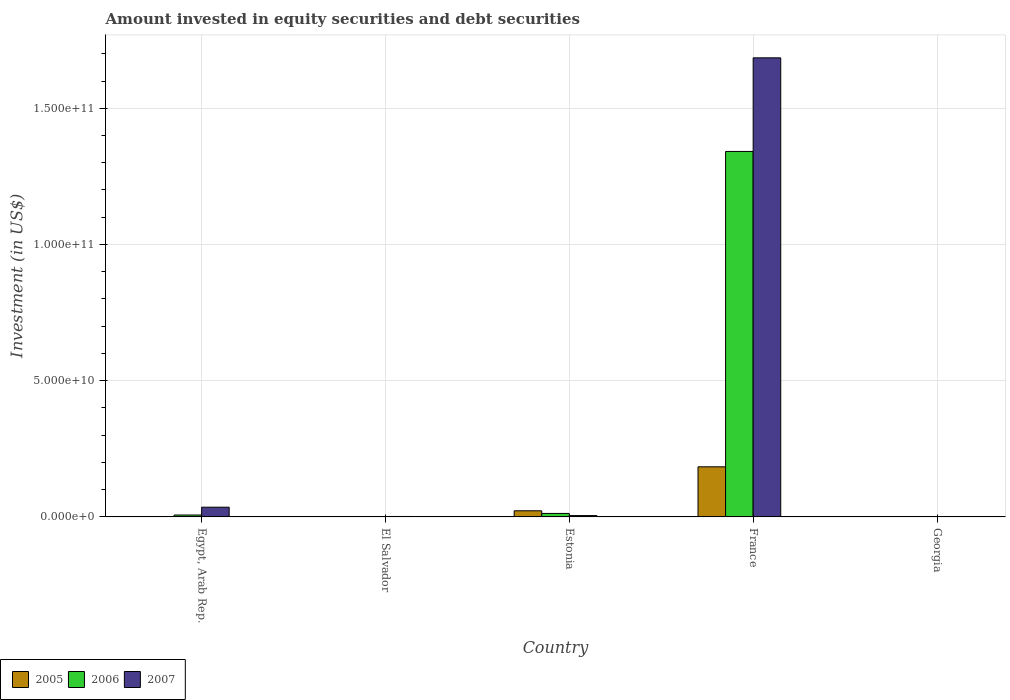Are the number of bars per tick equal to the number of legend labels?
Your answer should be very brief. No. What is the label of the 3rd group of bars from the left?
Your response must be concise. Estonia. What is the amount invested in equity securities and debt securities in 2007 in El Salvador?
Make the answer very short. 1.67e+08. Across all countries, what is the maximum amount invested in equity securities and debt securities in 2005?
Give a very brief answer. 1.84e+1. Across all countries, what is the minimum amount invested in equity securities and debt securities in 2005?
Offer a terse response. 0. What is the total amount invested in equity securities and debt securities in 2007 in the graph?
Offer a very short reply. 1.73e+11. What is the difference between the amount invested in equity securities and debt securities in 2007 in Egypt, Arab Rep. and that in France?
Make the answer very short. -1.65e+11. What is the difference between the amount invested in equity securities and debt securities in 2007 in Egypt, Arab Rep. and the amount invested in equity securities and debt securities in 2006 in Georgia?
Your response must be concise. 3.57e+09. What is the average amount invested in equity securities and debt securities in 2005 per country?
Your response must be concise. 4.13e+09. What is the difference between the amount invested in equity securities and debt securities of/in 2006 and amount invested in equity securities and debt securities of/in 2007 in Estonia?
Keep it short and to the point. 7.89e+08. In how many countries, is the amount invested in equity securities and debt securities in 2006 greater than 110000000000 US$?
Give a very brief answer. 1. What is the ratio of the amount invested in equity securities and debt securities in 2007 in Egypt, Arab Rep. to that in El Salvador?
Your response must be concise. 21.43. Is the difference between the amount invested in equity securities and debt securities in 2006 in Egypt, Arab Rep. and Estonia greater than the difference between the amount invested in equity securities and debt securities in 2007 in Egypt, Arab Rep. and Estonia?
Keep it short and to the point. No. What is the difference between the highest and the second highest amount invested in equity securities and debt securities in 2006?
Keep it short and to the point. 1.33e+11. What is the difference between the highest and the lowest amount invested in equity securities and debt securities in 2005?
Your response must be concise. 1.84e+1. How many countries are there in the graph?
Your answer should be compact. 5. Does the graph contain grids?
Keep it short and to the point. Yes. What is the title of the graph?
Give a very brief answer. Amount invested in equity securities and debt securities. Does "1980" appear as one of the legend labels in the graph?
Keep it short and to the point. No. What is the label or title of the X-axis?
Provide a short and direct response. Country. What is the label or title of the Y-axis?
Keep it short and to the point. Investment (in US$). What is the Investment (in US$) of 2005 in Egypt, Arab Rep.?
Your answer should be very brief. 0. What is the Investment (in US$) of 2006 in Egypt, Arab Rep.?
Your answer should be compact. 7.00e+08. What is the Investment (in US$) in 2007 in Egypt, Arab Rep.?
Make the answer very short. 3.57e+09. What is the Investment (in US$) of 2005 in El Salvador?
Your answer should be compact. 0. What is the Investment (in US$) of 2006 in El Salvador?
Your answer should be very brief. 0. What is the Investment (in US$) in 2007 in El Salvador?
Give a very brief answer. 1.67e+08. What is the Investment (in US$) of 2005 in Estonia?
Your response must be concise. 2.25e+09. What is the Investment (in US$) in 2006 in Estonia?
Ensure brevity in your answer.  1.28e+09. What is the Investment (in US$) in 2007 in Estonia?
Provide a succinct answer. 4.95e+08. What is the Investment (in US$) in 2005 in France?
Your response must be concise. 1.84e+1. What is the Investment (in US$) of 2006 in France?
Your answer should be compact. 1.34e+11. What is the Investment (in US$) of 2007 in France?
Offer a terse response. 1.69e+11. What is the Investment (in US$) in 2007 in Georgia?
Provide a succinct answer. 0. Across all countries, what is the maximum Investment (in US$) in 2005?
Your answer should be very brief. 1.84e+1. Across all countries, what is the maximum Investment (in US$) in 2006?
Your answer should be very brief. 1.34e+11. Across all countries, what is the maximum Investment (in US$) of 2007?
Your answer should be very brief. 1.69e+11. Across all countries, what is the minimum Investment (in US$) of 2005?
Offer a terse response. 0. Across all countries, what is the minimum Investment (in US$) of 2007?
Make the answer very short. 0. What is the total Investment (in US$) in 2005 in the graph?
Your answer should be very brief. 2.06e+1. What is the total Investment (in US$) of 2006 in the graph?
Offer a very short reply. 1.36e+11. What is the total Investment (in US$) of 2007 in the graph?
Your answer should be compact. 1.73e+11. What is the difference between the Investment (in US$) of 2007 in Egypt, Arab Rep. and that in El Salvador?
Offer a very short reply. 3.41e+09. What is the difference between the Investment (in US$) in 2006 in Egypt, Arab Rep. and that in Estonia?
Offer a very short reply. -5.83e+08. What is the difference between the Investment (in US$) in 2007 in Egypt, Arab Rep. and that in Estonia?
Keep it short and to the point. 3.08e+09. What is the difference between the Investment (in US$) of 2006 in Egypt, Arab Rep. and that in France?
Your answer should be compact. -1.33e+11. What is the difference between the Investment (in US$) in 2007 in Egypt, Arab Rep. and that in France?
Provide a succinct answer. -1.65e+11. What is the difference between the Investment (in US$) of 2007 in El Salvador and that in Estonia?
Make the answer very short. -3.28e+08. What is the difference between the Investment (in US$) in 2007 in El Salvador and that in France?
Keep it short and to the point. -1.68e+11. What is the difference between the Investment (in US$) in 2005 in Estonia and that in France?
Ensure brevity in your answer.  -1.61e+1. What is the difference between the Investment (in US$) in 2006 in Estonia and that in France?
Provide a succinct answer. -1.33e+11. What is the difference between the Investment (in US$) of 2007 in Estonia and that in France?
Give a very brief answer. -1.68e+11. What is the difference between the Investment (in US$) in 2006 in Egypt, Arab Rep. and the Investment (in US$) in 2007 in El Salvador?
Offer a terse response. 5.34e+08. What is the difference between the Investment (in US$) in 2006 in Egypt, Arab Rep. and the Investment (in US$) in 2007 in Estonia?
Your answer should be compact. 2.06e+08. What is the difference between the Investment (in US$) in 2006 in Egypt, Arab Rep. and the Investment (in US$) in 2007 in France?
Your answer should be compact. -1.68e+11. What is the difference between the Investment (in US$) of 2005 in Estonia and the Investment (in US$) of 2006 in France?
Keep it short and to the point. -1.32e+11. What is the difference between the Investment (in US$) in 2005 in Estonia and the Investment (in US$) in 2007 in France?
Your answer should be very brief. -1.66e+11. What is the difference between the Investment (in US$) in 2006 in Estonia and the Investment (in US$) in 2007 in France?
Give a very brief answer. -1.67e+11. What is the average Investment (in US$) of 2005 per country?
Your answer should be very brief. 4.13e+09. What is the average Investment (in US$) of 2006 per country?
Offer a very short reply. 2.72e+1. What is the average Investment (in US$) in 2007 per country?
Your answer should be compact. 3.45e+1. What is the difference between the Investment (in US$) in 2006 and Investment (in US$) in 2007 in Egypt, Arab Rep.?
Your answer should be compact. -2.87e+09. What is the difference between the Investment (in US$) in 2005 and Investment (in US$) in 2006 in Estonia?
Provide a succinct answer. 9.71e+08. What is the difference between the Investment (in US$) of 2005 and Investment (in US$) of 2007 in Estonia?
Offer a terse response. 1.76e+09. What is the difference between the Investment (in US$) of 2006 and Investment (in US$) of 2007 in Estonia?
Keep it short and to the point. 7.89e+08. What is the difference between the Investment (in US$) of 2005 and Investment (in US$) of 2006 in France?
Your response must be concise. -1.16e+11. What is the difference between the Investment (in US$) in 2005 and Investment (in US$) in 2007 in France?
Your response must be concise. -1.50e+11. What is the difference between the Investment (in US$) of 2006 and Investment (in US$) of 2007 in France?
Your answer should be very brief. -3.44e+1. What is the ratio of the Investment (in US$) of 2007 in Egypt, Arab Rep. to that in El Salvador?
Offer a very short reply. 21.43. What is the ratio of the Investment (in US$) in 2006 in Egypt, Arab Rep. to that in Estonia?
Your answer should be compact. 0.55. What is the ratio of the Investment (in US$) of 2007 in Egypt, Arab Rep. to that in Estonia?
Your answer should be very brief. 7.22. What is the ratio of the Investment (in US$) of 2006 in Egypt, Arab Rep. to that in France?
Offer a terse response. 0.01. What is the ratio of the Investment (in US$) in 2007 in Egypt, Arab Rep. to that in France?
Offer a terse response. 0.02. What is the ratio of the Investment (in US$) of 2007 in El Salvador to that in Estonia?
Keep it short and to the point. 0.34. What is the ratio of the Investment (in US$) of 2007 in El Salvador to that in France?
Provide a succinct answer. 0. What is the ratio of the Investment (in US$) of 2005 in Estonia to that in France?
Your response must be concise. 0.12. What is the ratio of the Investment (in US$) of 2006 in Estonia to that in France?
Keep it short and to the point. 0.01. What is the ratio of the Investment (in US$) of 2007 in Estonia to that in France?
Provide a succinct answer. 0. What is the difference between the highest and the second highest Investment (in US$) in 2006?
Provide a succinct answer. 1.33e+11. What is the difference between the highest and the second highest Investment (in US$) of 2007?
Give a very brief answer. 1.65e+11. What is the difference between the highest and the lowest Investment (in US$) of 2005?
Your response must be concise. 1.84e+1. What is the difference between the highest and the lowest Investment (in US$) of 2006?
Provide a succinct answer. 1.34e+11. What is the difference between the highest and the lowest Investment (in US$) of 2007?
Make the answer very short. 1.69e+11. 